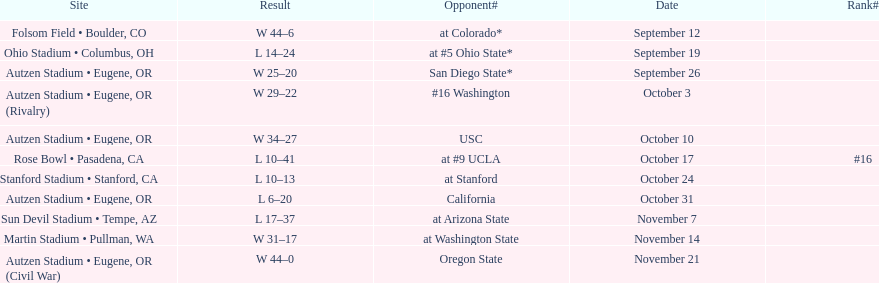What is the number of away games ? 6. 